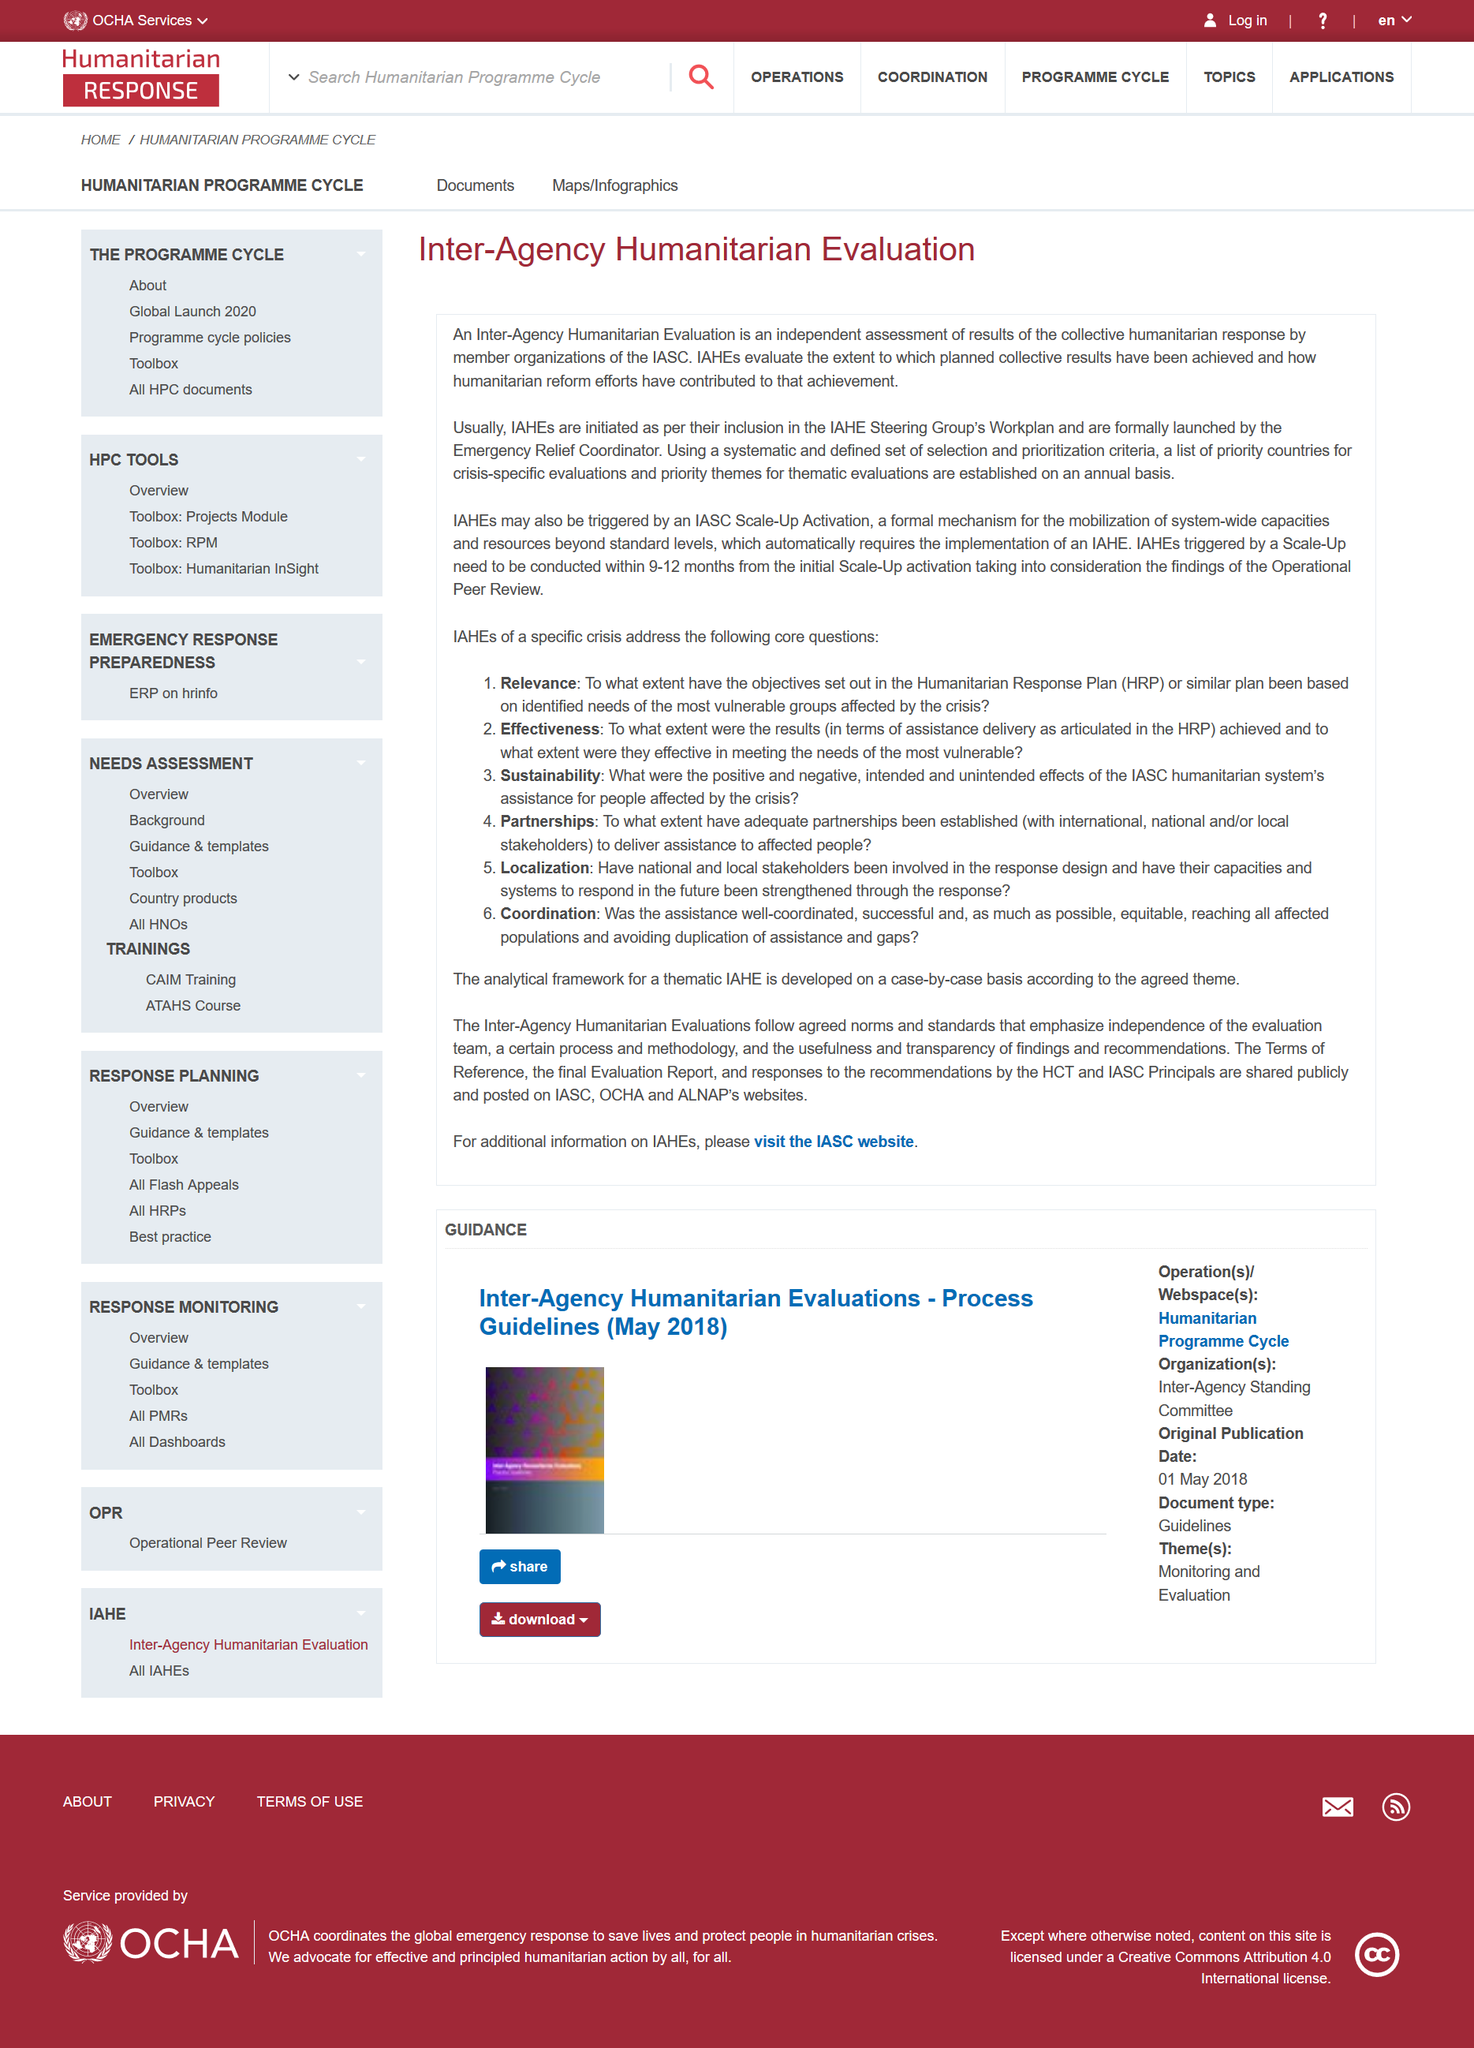List a handful of essential elements in this visual. Inter-Agency Humanitarian Evaluations are initiated either due to their inclusion in the IAHE Steering Group's workplan or upon an IASC Scale-up Activation. It is recommended that Integracore Activation of Higher Evolution (IAHE) events triggered by a need be conducted within 9-12 months after the initial Scale-Up activation. Inter-Agency Humanitarian Evaluation (IAHE) is a process used to assess the effectiveness and impact of humanitarian aid efforts. 